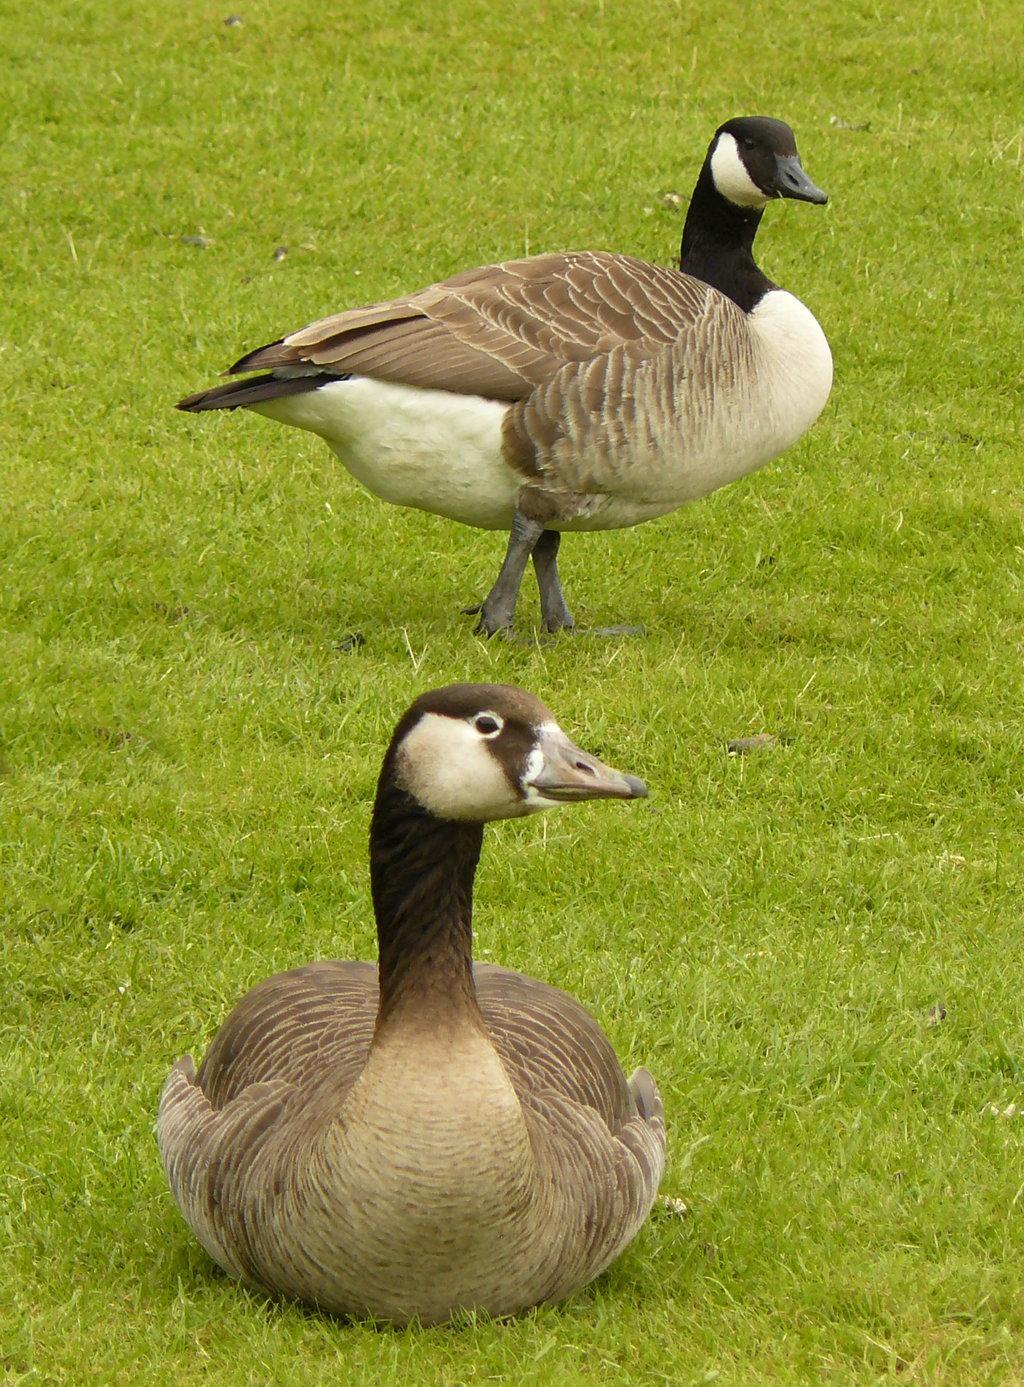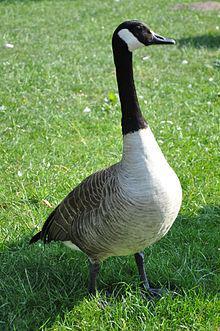The first image is the image on the left, the second image is the image on the right. For the images shown, is this caption "Two black-necked geese with backs to the camera are standing in water." true? Answer yes or no. No. The first image is the image on the left, the second image is the image on the right. Given the left and right images, does the statement "There are two birds in the right image both facing towards the left." hold true? Answer yes or no. No. 